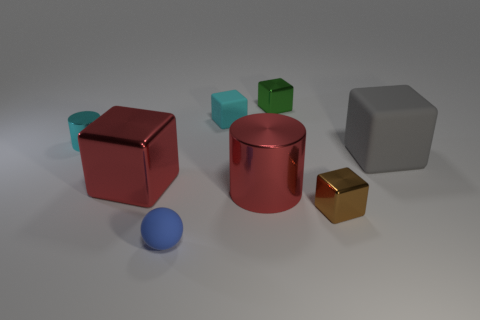Subtract all large blocks. How many blocks are left? 3 Add 1 metallic cubes. How many objects exist? 9 Subtract all red cubes. How many cubes are left? 4 Subtract all cylinders. How many objects are left? 6 Add 4 small purple metal cubes. How many small purple metal cubes exist? 4 Subtract 0 brown spheres. How many objects are left? 8 Subtract 5 cubes. How many cubes are left? 0 Subtract all brown cylinders. Subtract all green blocks. How many cylinders are left? 2 Subtract all brown cylinders. How many cyan spheres are left? 0 Subtract all large metallic blocks. Subtract all tiny rubber objects. How many objects are left? 5 